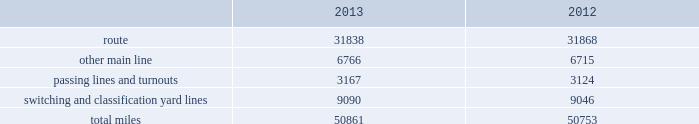Item 2 .
Properties we employ a variety of assets in the management and operation of our rail business .
Our rail network covers 23 states in the western two-thirds of the u.s .
Our rail network includes 31838 route miles .
We own 26009 miles and operate on the remainder pursuant to trackage rights or leases .
The table describes track miles at december 31 , 2013 and 2012 .
2013 2012 .
Headquarters building we maintain our headquarters in omaha , nebraska .
The facility has 1.2 million square feet of space for approximately 4000 employees and is subject to a financing arrangement .
Harriman dispatching center the harriman dispatching center ( hdc ) , located in omaha , nebraska , is our primary dispatching facility .
It is linked to regional dispatching and locomotive management facilities at various locations along our .
What percentage of total miles of track were switching and classification yard lines in 2013? 
Computations: (9090 / 50861)
Answer: 0.17872. 